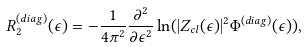Convert formula to latex. <formula><loc_0><loc_0><loc_500><loc_500>R _ { 2 } ^ { ( d i a g ) } ( \epsilon ) = - \frac { 1 } { 4 \pi ^ { 2 } } \frac { \partial ^ { 2 } } { \partial \epsilon ^ { 2 } } \ln ( | Z _ { c l } ( \epsilon ) | ^ { 2 } \Phi ^ { ( d i a g ) } ( \epsilon ) ) ,</formula> 